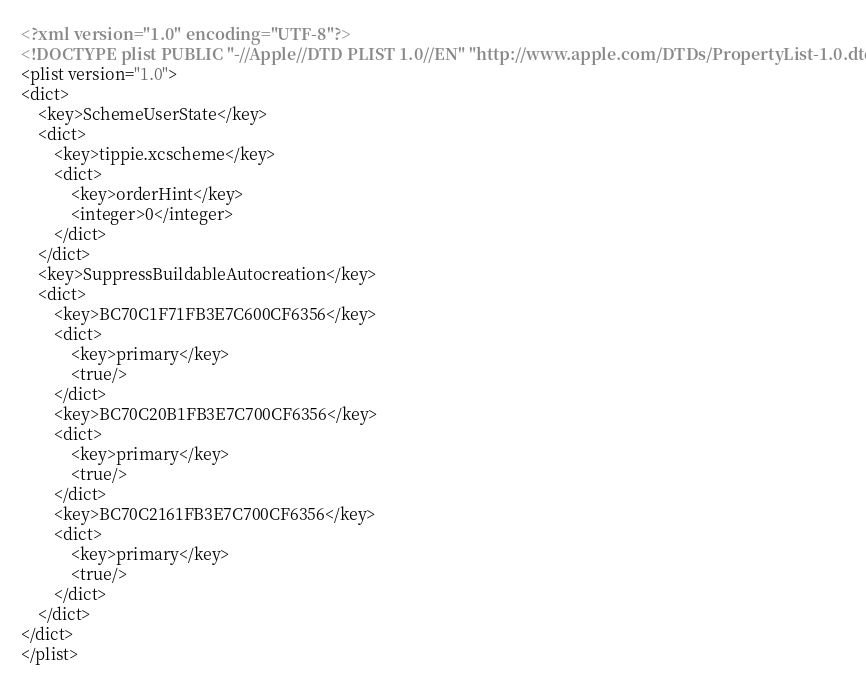Convert code to text. <code><loc_0><loc_0><loc_500><loc_500><_XML_><?xml version="1.0" encoding="UTF-8"?>
<!DOCTYPE plist PUBLIC "-//Apple//DTD PLIST 1.0//EN" "http://www.apple.com/DTDs/PropertyList-1.0.dtd">
<plist version="1.0">
<dict>
	<key>SchemeUserState</key>
	<dict>
		<key>tippie.xcscheme</key>
		<dict>
			<key>orderHint</key>
			<integer>0</integer>
		</dict>
	</dict>
	<key>SuppressBuildableAutocreation</key>
	<dict>
		<key>BC70C1F71FB3E7C600CF6356</key>
		<dict>
			<key>primary</key>
			<true/>
		</dict>
		<key>BC70C20B1FB3E7C700CF6356</key>
		<dict>
			<key>primary</key>
			<true/>
		</dict>
		<key>BC70C2161FB3E7C700CF6356</key>
		<dict>
			<key>primary</key>
			<true/>
		</dict>
	</dict>
</dict>
</plist>
</code> 